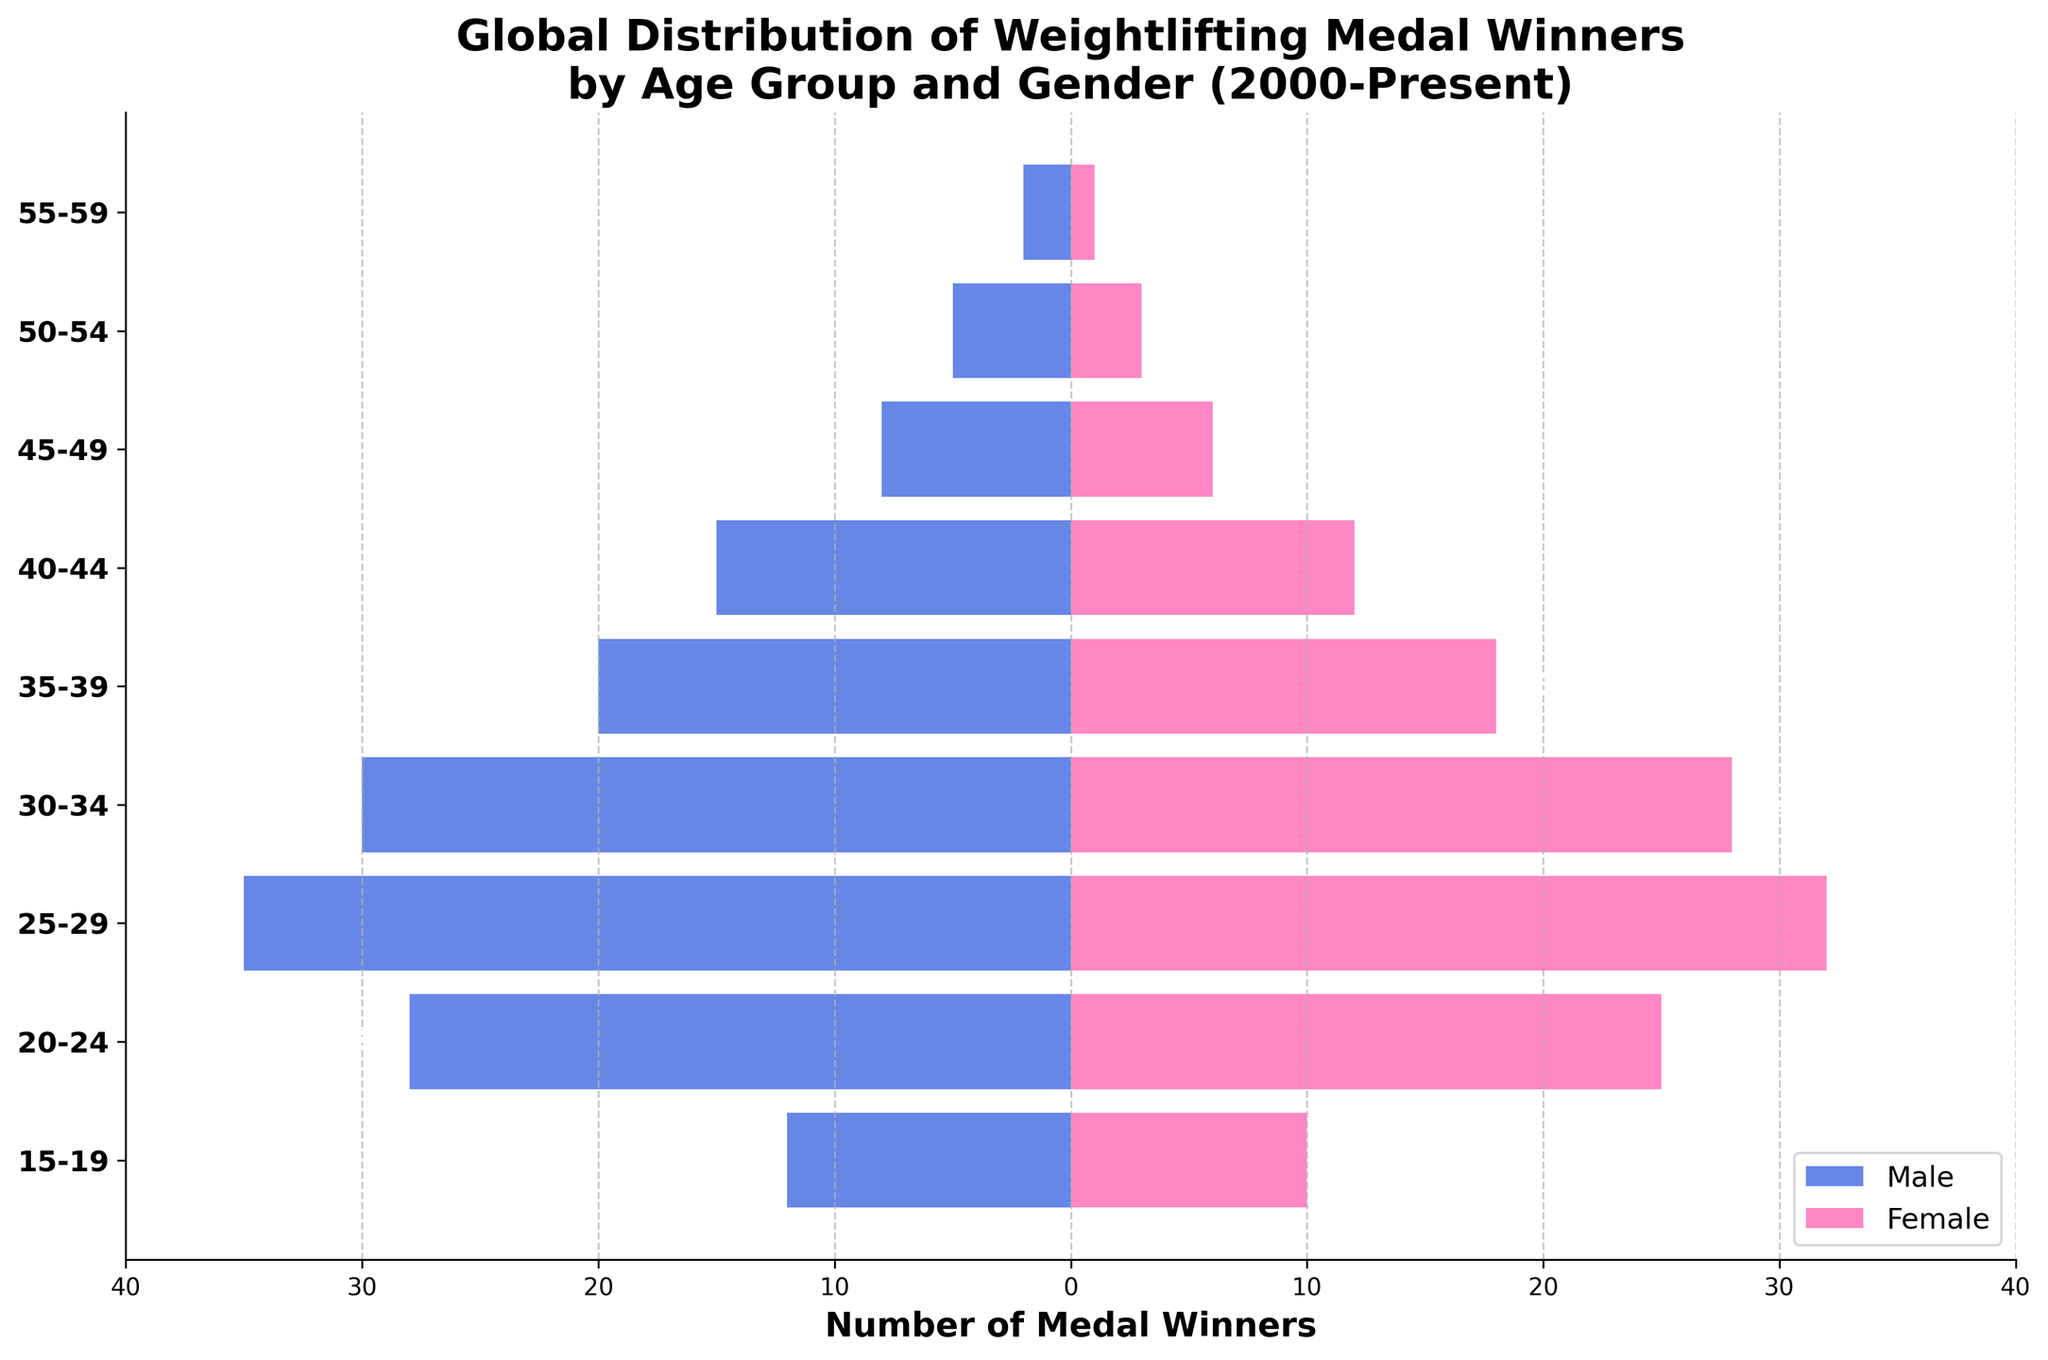What is the title of the figure? The title of the figure is located at the top and immediately provides an overview of what the plot represents. Here, the title in bold and large font reads: "Global Distribution of Weightlifting Medal Winners by Age Group and Gender (2000-Present)."
Answer: Global Distribution of Weightlifting Medal Winners by Age Group and Gender (2000-Present) Which group has the highest number of male medal winners? To determine this, look for the longest bar extending to the left side of the y-axis. The age group '25-29' has the largest negative value, indicating the highest number of male medal winners at -35.
Answer: 25-29 How many age groups are represented in the figure? The y-axis lists the age groups, which are labeled along the left side. Counting these, we observe 9 distinct age groups ranging from '15-19' to '55-59.'
Answer: 9 Which age group shows a significant difference in the number of male and female medal winners, and what is this difference? Examine the differences in the lengths of the bars for each age group. The age group '25-29' has the largest difference: males have -35 and females have 32 medal winners, so the difference is 67.
Answer: 25-29, 67 How does the number of female medal winners in the 20-24 age group compare to the 50-54 age group? Compare the lengths of the pink bars for these two age groups. The 20-24 age group has 25 female winners, while the 50-54 group has 3 female winners. This indicates that the 20-24 group has 22 more winners than the 50-54 group.
Answer: 22 more winners What's the total number of female medal winners across all age groups? Sum the female values for all age groups: 10 + 25 + 32 + 28 + 18 + 12 + 6 + 3 + 1 = 135.
Answer: 135 Compare the gender distribution in the 35-39 age group. Which gender has more medal winners and by how much? In the 35-39 age group, the blue bar (male) has a value of -20, while the pink bar (female) has a value of 18. Therefore, there are 2 more male winners than female winners.
Answer: Males, 2 What is the trend in the number of male medal winners as the age groups increase? Observing the blue bars moving downward through age groups, the general trend shows a decrease in the number of male winners. This starts high in '25-29' and decreases progressively in older age groups.
Answer: Decreasing trend Is there any age group in which the number of male and female medal winners is the same? By comparing the heights of the bars of males and females in each age group, none of them are equal.
Answer: No What is the smallest number of medal winners for any gender in any age group? Identify the smallest absolute value across both genders. The smallest values are 1 (female in 55-59) and 2 (male in 55-59).
Answer: 1 